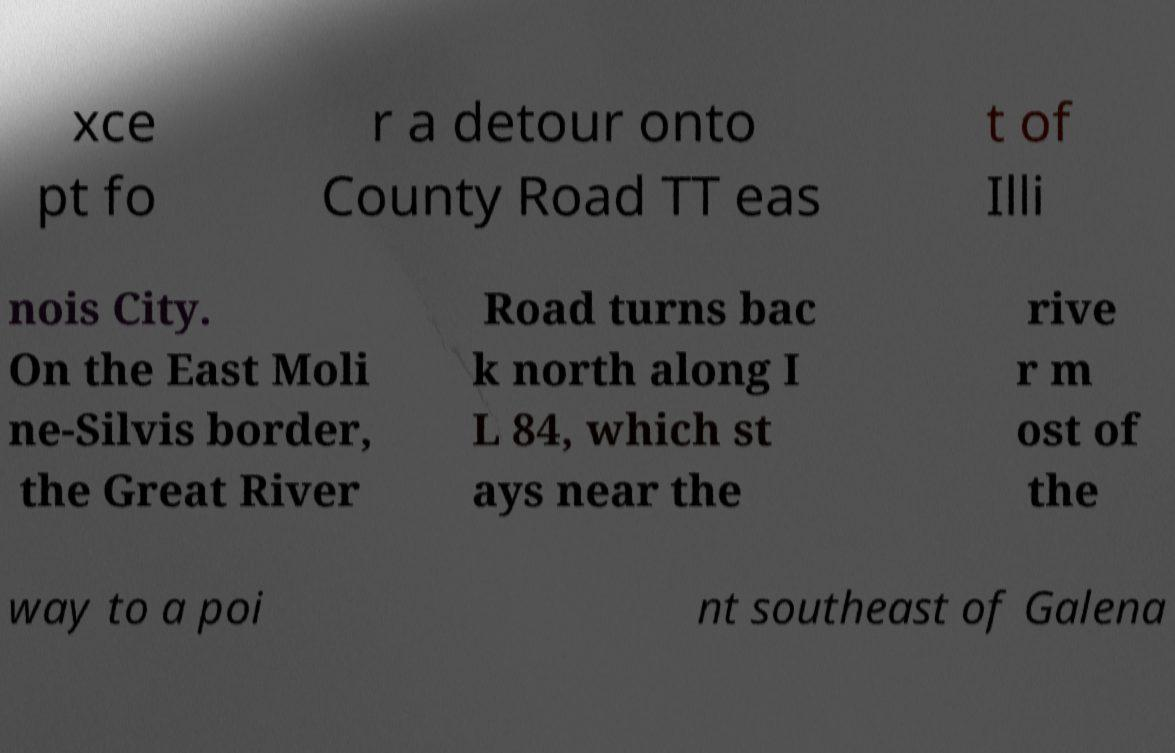Can you read and provide the text displayed in the image?This photo seems to have some interesting text. Can you extract and type it out for me? xce pt fo r a detour onto County Road TT eas t of Illi nois City. On the East Moli ne-Silvis border, the Great River Road turns bac k north along I L 84, which st ays near the rive r m ost of the way to a poi nt southeast of Galena 